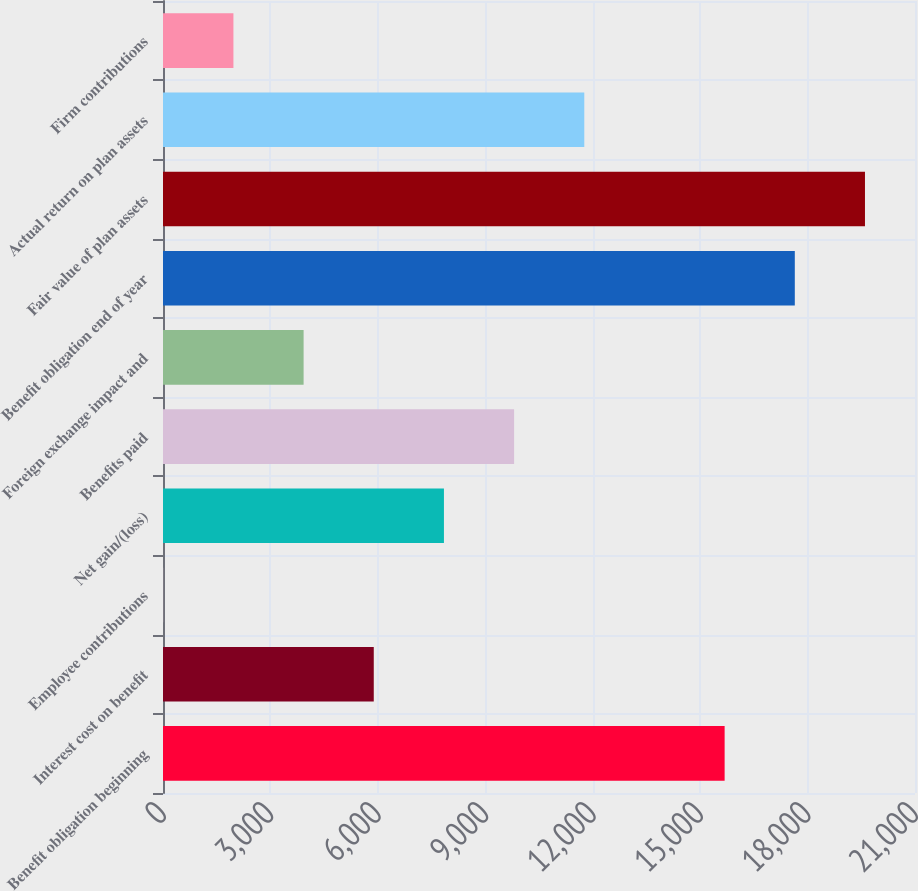Convert chart. <chart><loc_0><loc_0><loc_500><loc_500><bar_chart><fcel>Benefit obligation beginning<fcel>Interest cost on benefit<fcel>Employee contributions<fcel>Net gain/(loss)<fcel>Benefits paid<fcel>Foreign exchange impact and<fcel>Benefit obligation end of year<fcel>Fair value of plan assets<fcel>Actual return on plan assets<fcel>Firm contributions<nl><fcel>15683.8<fcel>5885.8<fcel>7<fcel>7845.4<fcel>9805<fcel>3926.2<fcel>17643.4<fcel>19603<fcel>11764.6<fcel>1966.6<nl></chart> 